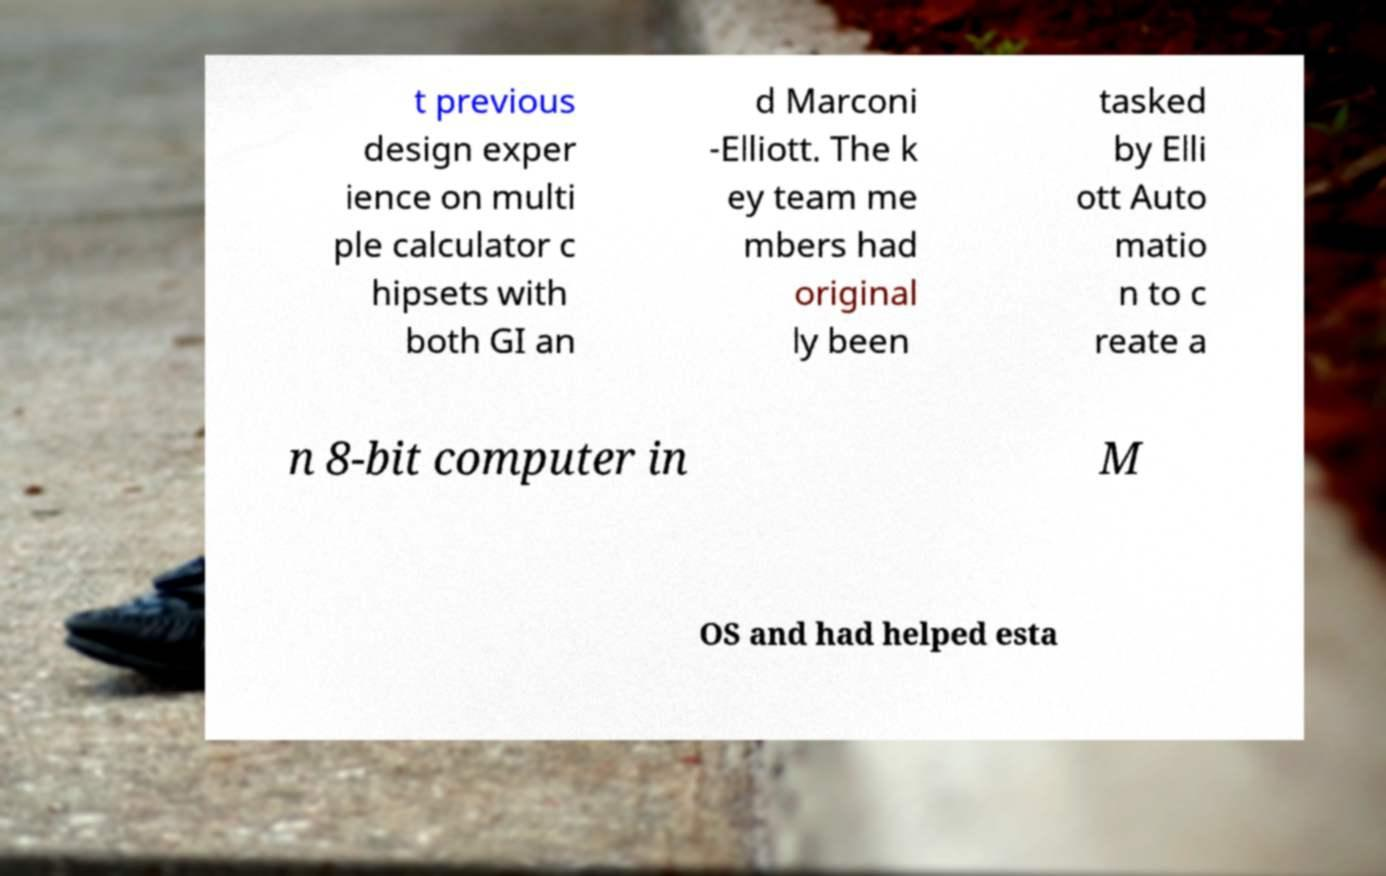Could you assist in decoding the text presented in this image and type it out clearly? t previous design exper ience on multi ple calculator c hipsets with both GI an d Marconi -Elliott. The k ey team me mbers had original ly been tasked by Elli ott Auto matio n to c reate a n 8-bit computer in M OS and had helped esta 